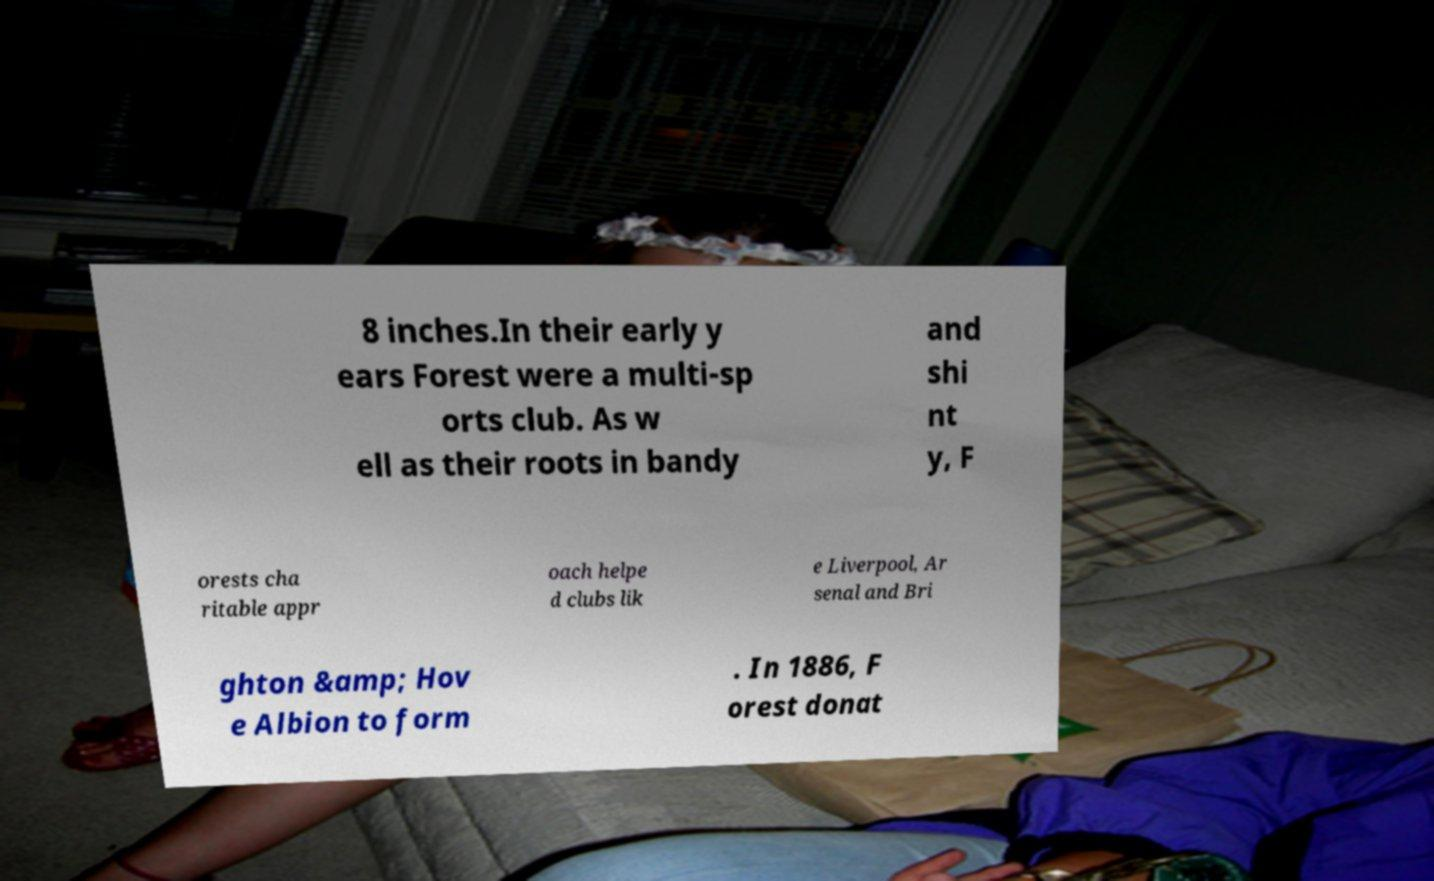Could you assist in decoding the text presented in this image and type it out clearly? 8 inches.In their early y ears Forest were a multi-sp orts club. As w ell as their roots in bandy and shi nt y, F orests cha ritable appr oach helpe d clubs lik e Liverpool, Ar senal and Bri ghton &amp; Hov e Albion to form . In 1886, F orest donat 